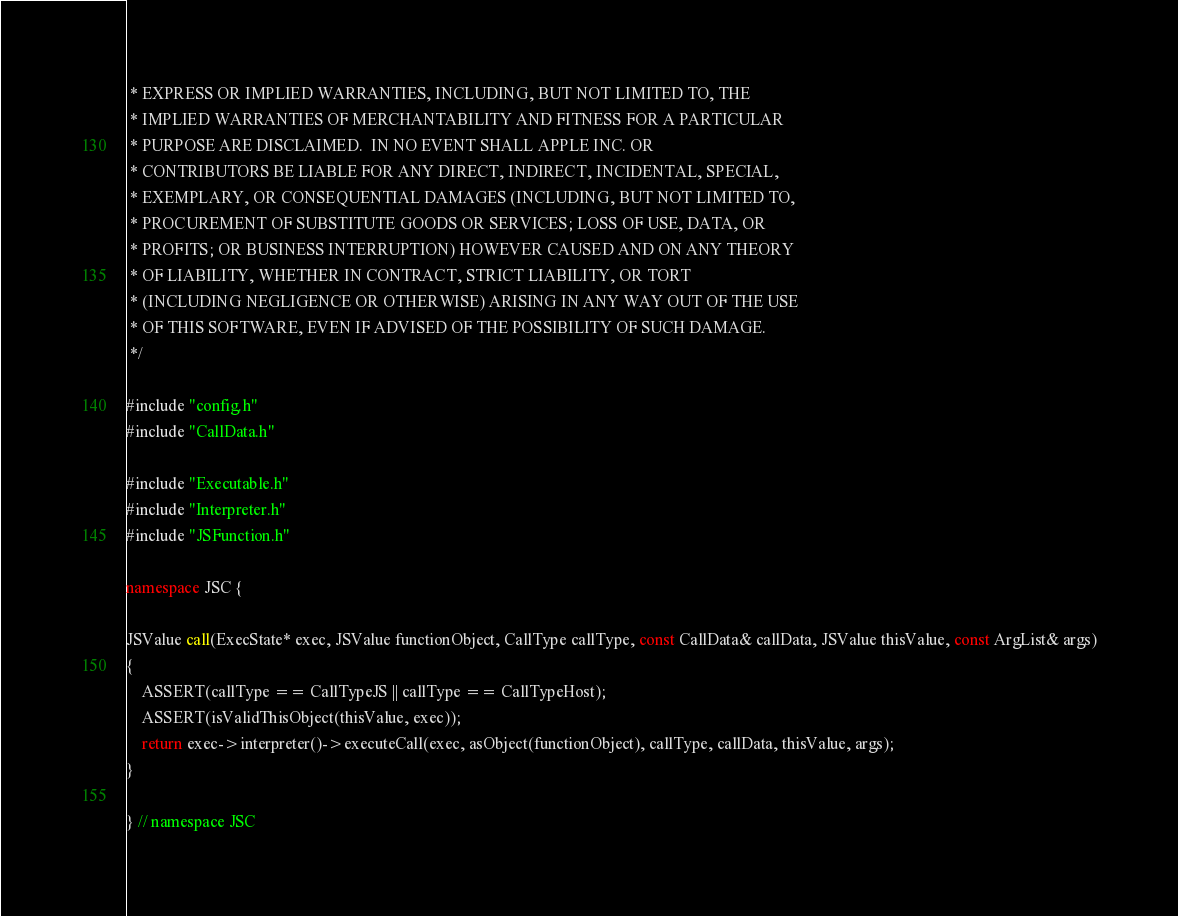<code> <loc_0><loc_0><loc_500><loc_500><_C++_> * EXPRESS OR IMPLIED WARRANTIES, INCLUDING, BUT NOT LIMITED TO, THE
 * IMPLIED WARRANTIES OF MERCHANTABILITY AND FITNESS FOR A PARTICULAR
 * PURPOSE ARE DISCLAIMED.  IN NO EVENT SHALL APPLE INC. OR
 * CONTRIBUTORS BE LIABLE FOR ANY DIRECT, INDIRECT, INCIDENTAL, SPECIAL,
 * EXEMPLARY, OR CONSEQUENTIAL DAMAGES (INCLUDING, BUT NOT LIMITED TO,
 * PROCUREMENT OF SUBSTITUTE GOODS OR SERVICES; LOSS OF USE, DATA, OR
 * PROFITS; OR BUSINESS INTERRUPTION) HOWEVER CAUSED AND ON ANY THEORY
 * OF LIABILITY, WHETHER IN CONTRACT, STRICT LIABILITY, OR TORT
 * (INCLUDING NEGLIGENCE OR OTHERWISE) ARISING IN ANY WAY OUT OF THE USE
 * OF THIS SOFTWARE, EVEN IF ADVISED OF THE POSSIBILITY OF SUCH DAMAGE. 
 */

#include "config.h"
#include "CallData.h"

#include "Executable.h"
#include "Interpreter.h"
#include "JSFunction.h"

namespace JSC {

JSValue call(ExecState* exec, JSValue functionObject, CallType callType, const CallData& callData, JSValue thisValue, const ArgList& args)
{
    ASSERT(callType == CallTypeJS || callType == CallTypeHost);
    ASSERT(isValidThisObject(thisValue, exec));
    return exec->interpreter()->executeCall(exec, asObject(functionObject), callType, callData, thisValue, args);
}

} // namespace JSC
</code> 